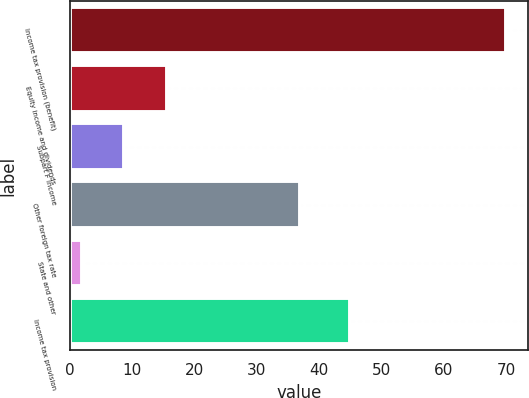Convert chart. <chart><loc_0><loc_0><loc_500><loc_500><bar_chart><fcel>Income tax provision (benefit)<fcel>Equity income and dividends<fcel>Subpart F income<fcel>Other foreign tax rate<fcel>State and other<fcel>Income tax provision<nl><fcel>70<fcel>15.6<fcel>8.8<fcel>37<fcel>2<fcel>45<nl></chart> 